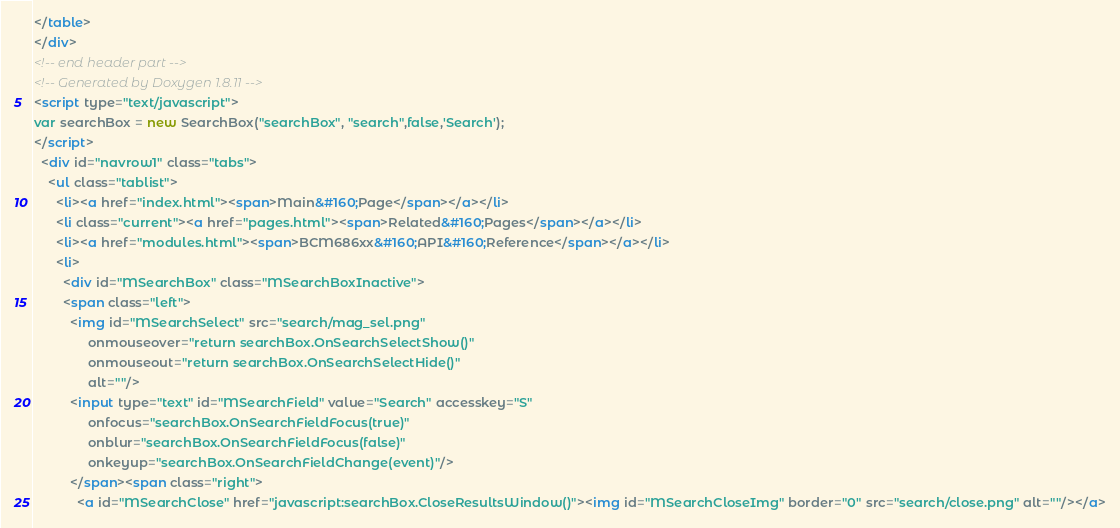Convert code to text. <code><loc_0><loc_0><loc_500><loc_500><_HTML_></table>
</div>
<!-- end header part -->
<!-- Generated by Doxygen 1.8.11 -->
<script type="text/javascript">
var searchBox = new SearchBox("searchBox", "search",false,'Search');
</script>
  <div id="navrow1" class="tabs">
    <ul class="tablist">
      <li><a href="index.html"><span>Main&#160;Page</span></a></li>
      <li class="current"><a href="pages.html"><span>Related&#160;Pages</span></a></li>
      <li><a href="modules.html"><span>BCM686xx&#160;API&#160;Reference</span></a></li>
      <li>
        <div id="MSearchBox" class="MSearchBoxInactive">
        <span class="left">
          <img id="MSearchSelect" src="search/mag_sel.png"
               onmouseover="return searchBox.OnSearchSelectShow()"
               onmouseout="return searchBox.OnSearchSelectHide()"
               alt=""/>
          <input type="text" id="MSearchField" value="Search" accesskey="S"
               onfocus="searchBox.OnSearchFieldFocus(true)" 
               onblur="searchBox.OnSearchFieldFocus(false)" 
               onkeyup="searchBox.OnSearchFieldChange(event)"/>
          </span><span class="right">
            <a id="MSearchClose" href="javascript:searchBox.CloseResultsWindow()"><img id="MSearchCloseImg" border="0" src="search/close.png" alt=""/></a></code> 